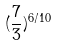Convert formula to latex. <formula><loc_0><loc_0><loc_500><loc_500>( \frac { 7 } { 3 } ) ^ { 6 / 1 0 }</formula> 